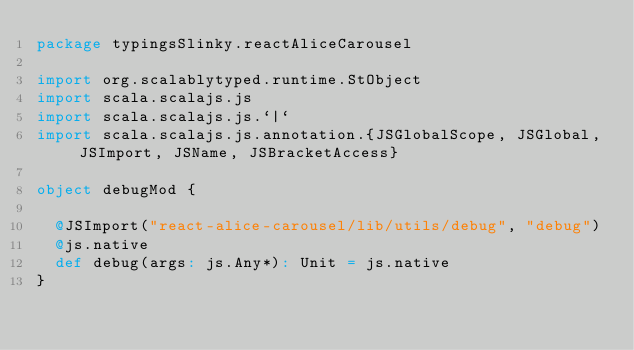Convert code to text. <code><loc_0><loc_0><loc_500><loc_500><_Scala_>package typingsSlinky.reactAliceCarousel

import org.scalablytyped.runtime.StObject
import scala.scalajs.js
import scala.scalajs.js.`|`
import scala.scalajs.js.annotation.{JSGlobalScope, JSGlobal, JSImport, JSName, JSBracketAccess}

object debugMod {
  
  @JSImport("react-alice-carousel/lib/utils/debug", "debug")
  @js.native
  def debug(args: js.Any*): Unit = js.native
}
</code> 